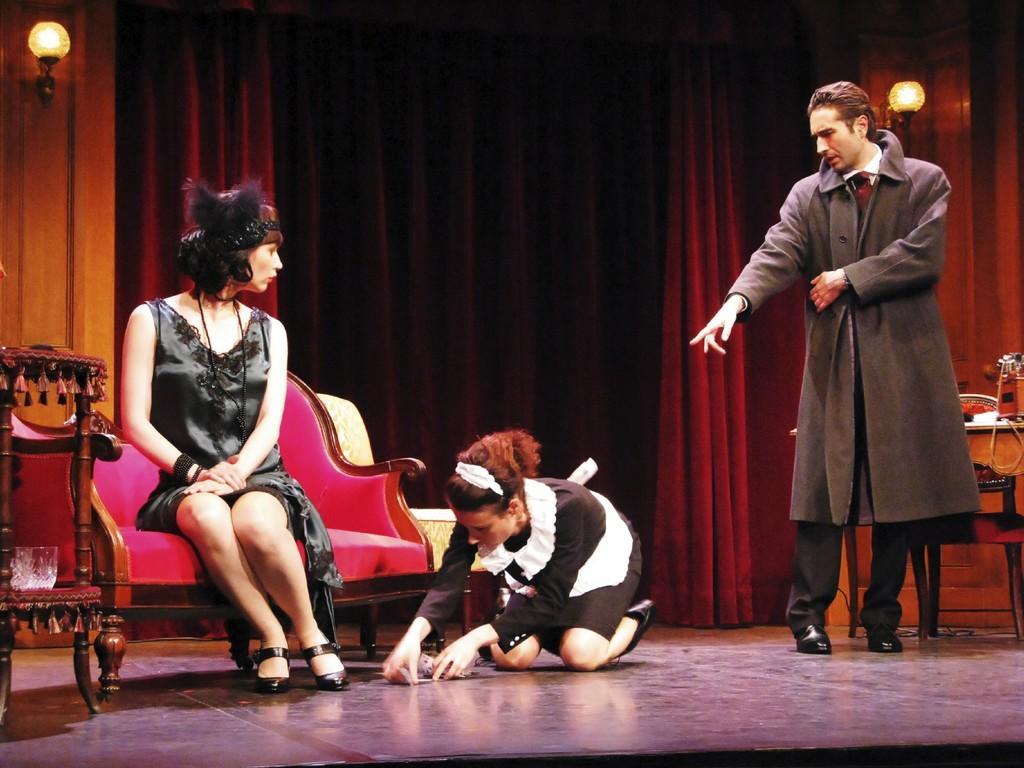Please provide a concise description of this image. Here in this picture we can see three people present on the floor over there and the person on the right side is standing and he is wearing a coat on him and beside him we can see another person kneeling down on the floor over there and beside her we can see a woman sitting on the chair over there and behind them we can see lamp posts present and we can see curtains present over there. 